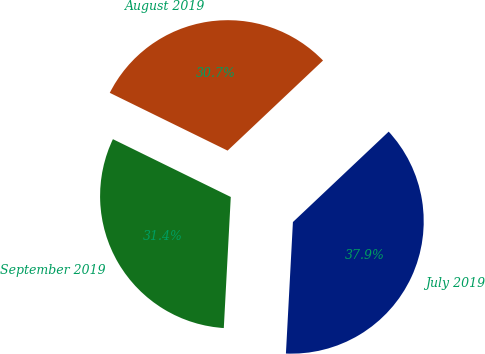Convert chart. <chart><loc_0><loc_0><loc_500><loc_500><pie_chart><fcel>July 2019<fcel>August 2019<fcel>September 2019<nl><fcel>37.89%<fcel>30.7%<fcel>31.41%<nl></chart> 